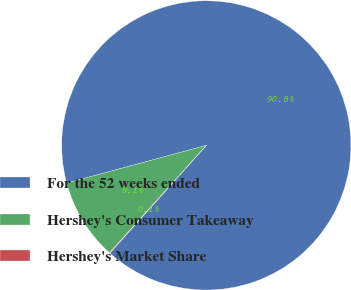Convert chart. <chart><loc_0><loc_0><loc_500><loc_500><pie_chart><fcel>For the 52 weeks ended<fcel>Hershey's Consumer Takeaway<fcel>Hershey's Market Share<nl><fcel>90.82%<fcel>9.13%<fcel>0.05%<nl></chart> 